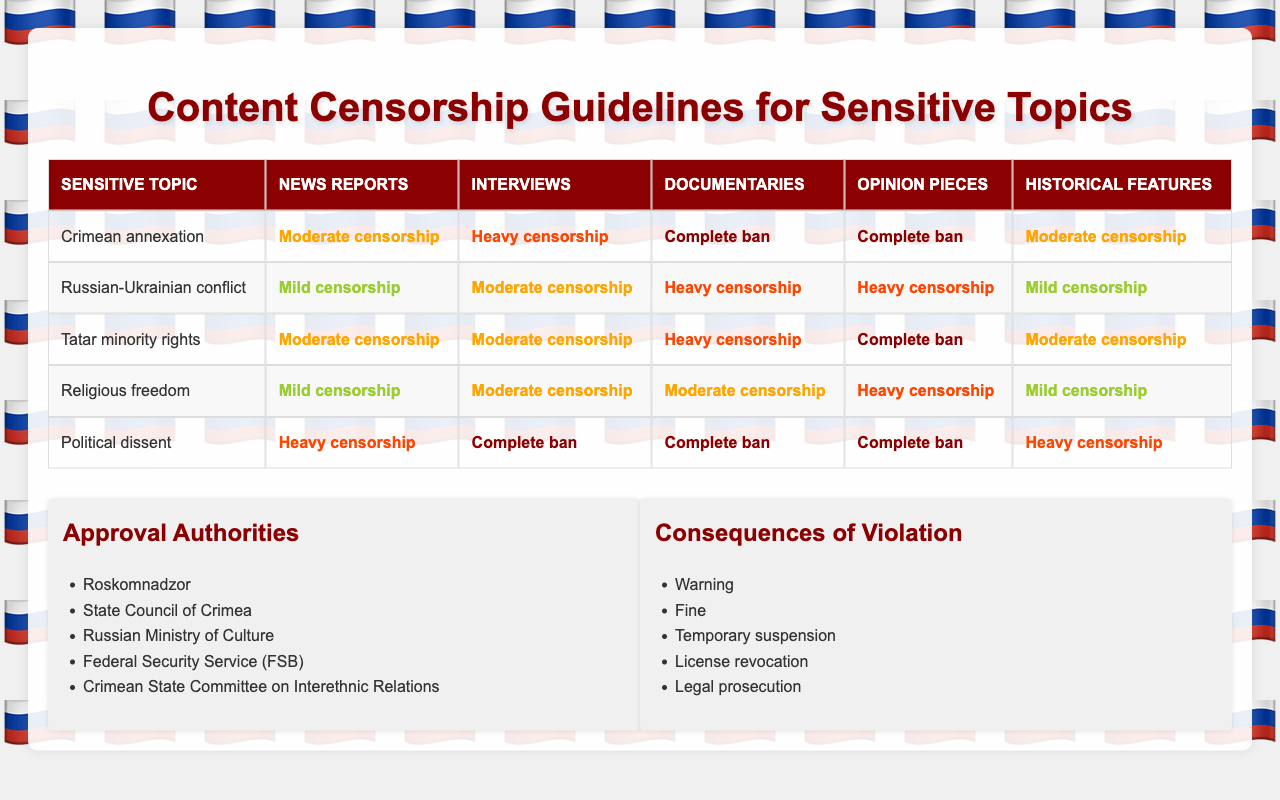What is the censorship level for news reports on Tatar minority rights? According to the table, news reports about Tatar minority rights are subject to moderate censorship.
Answer: Moderate censorship Is there a complete ban on documentaries for the topic of Crimean annexation? The table shows that documentaries related to Crimean annexation have a complete ban.
Answer: Yes Which sensitive topic has the highest censorship level for interviews? Looking at the table, Political dissent has the highest censorship level for interviews, which is a complete ban.
Answer: Political dissent What is the average censorship level for historical features across all topics? To calculate the average, we assign numerical values to the censorship levels (No censorship = 0, Mild censorship = 1, Moderate censorship = 2, Heavy censorship = 3, Complete ban = 4). For historical features, the values are (2, 1, 2, 1, 3). The total is 9, with 5 topics, giving an average of 9/5 = 1.8, which corresponds to mild to moderate censorship.
Answer: Mild to moderate censorship Are there any topics where opinion pieces are allowed without censorship? Checking the table, all entries for opinion pieces are either heavily censored or completely banned, indicating there are no topics allowing opinion pieces without censorship.
Answer: No What is the consequence of violation associated with heavy censorship in news reports? The table does not explicitly state a single consequence linked to heavy censorship for news reports, but common consequences include a warning or fine. Since heavy censorship indicates serious restriction, it can lead to more severe actions like temporary suspension or license revocation depending on the violation severity as mentioned under consequences.
Answer: Varies by situation, severe consequences possible For which sensitive topic is the censorship level for documentaries the least strict? The Russian-Ukrainian conflict has the least strict censorship level for documentaries, classified as heavy censorship, while other topics face complete bans or higher levels of censorship.
Answer: Russian-Ukrainian conflict How does the censorship level for interviews on Religious freedom compare to that of Political dissent? The table indicates that interviews on Religious freedom face moderate censorship, whereas Political dissent has a complete ban on interviews. Therefore, Religious freedom is less restricted for interviews compared to Political dissent.
Answer: Less restrictive Which sensitive topic has the same censorship level for both news reports and historical features? Tatar minority rights and Crimean annexation both have a moderate censorship level for news reports (2) and historical features (2), indicating consistent censorship levels for these content types.
Answer: Tatar minority rights and Crimean annexation 